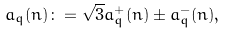<formula> <loc_0><loc_0><loc_500><loc_500>a _ { q } ( n ) \colon = \sqrt { 3 } a ^ { + } _ { q } ( n ) \pm a ^ { - } _ { q } ( n ) ,</formula> 